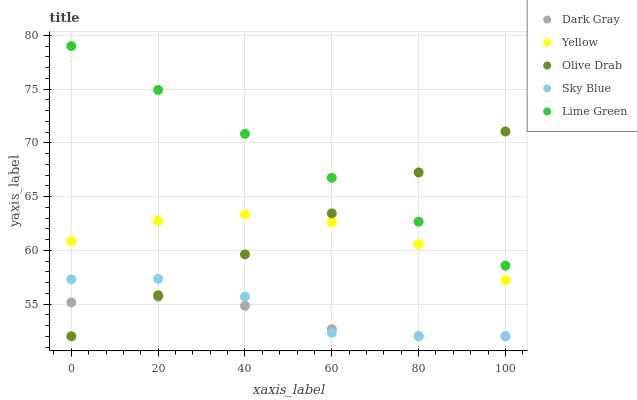Does Dark Gray have the minimum area under the curve?
Answer yes or no. Yes. Does Lime Green have the maximum area under the curve?
Answer yes or no. Yes. Does Sky Blue have the minimum area under the curve?
Answer yes or no. No. Does Sky Blue have the maximum area under the curve?
Answer yes or no. No. Is Olive Drab the smoothest?
Answer yes or no. Yes. Is Sky Blue the roughest?
Answer yes or no. Yes. Is Lime Green the smoothest?
Answer yes or no. No. Is Lime Green the roughest?
Answer yes or no. No. Does Dark Gray have the lowest value?
Answer yes or no. Yes. Does Lime Green have the lowest value?
Answer yes or no. No. Does Lime Green have the highest value?
Answer yes or no. Yes. Does Sky Blue have the highest value?
Answer yes or no. No. Is Sky Blue less than Lime Green?
Answer yes or no. Yes. Is Yellow greater than Sky Blue?
Answer yes or no. Yes. Does Sky Blue intersect Dark Gray?
Answer yes or no. Yes. Is Sky Blue less than Dark Gray?
Answer yes or no. No. Is Sky Blue greater than Dark Gray?
Answer yes or no. No. Does Sky Blue intersect Lime Green?
Answer yes or no. No. 